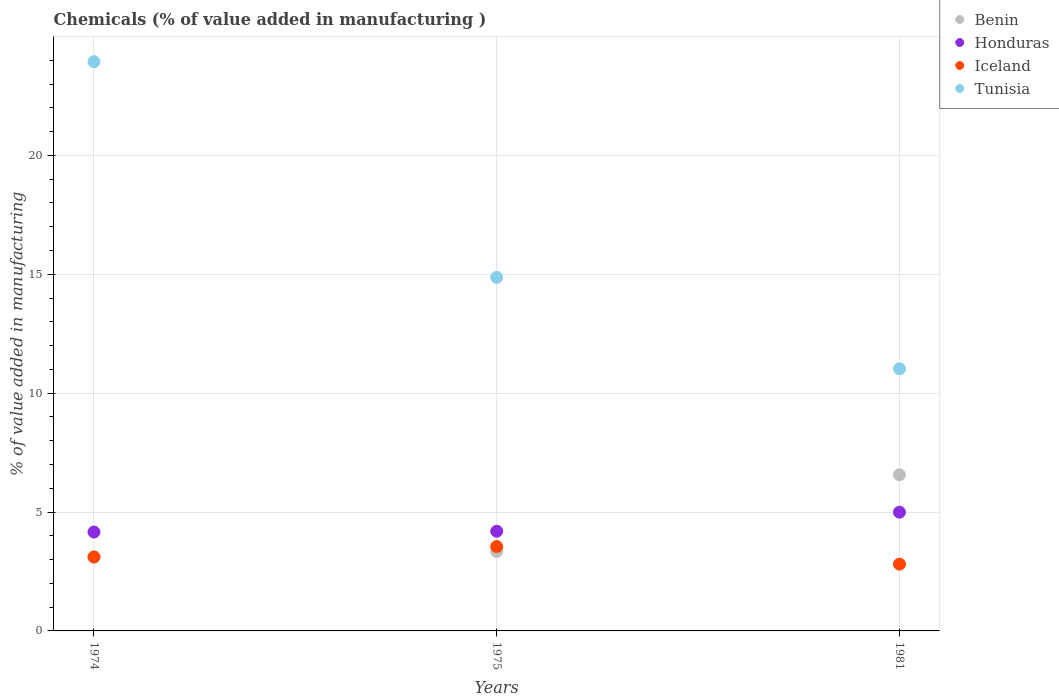Is the number of dotlines equal to the number of legend labels?
Make the answer very short. Yes. What is the value added in manufacturing chemicals in Tunisia in 1974?
Offer a terse response. 23.94. Across all years, what is the maximum value added in manufacturing chemicals in Tunisia?
Offer a very short reply. 23.94. Across all years, what is the minimum value added in manufacturing chemicals in Honduras?
Give a very brief answer. 4.16. In which year was the value added in manufacturing chemicals in Benin maximum?
Provide a short and direct response. 1981. In which year was the value added in manufacturing chemicals in Benin minimum?
Your response must be concise. 1974. What is the total value added in manufacturing chemicals in Benin in the graph?
Provide a short and direct response. 13.01. What is the difference between the value added in manufacturing chemicals in Tunisia in 1974 and that in 1981?
Offer a very short reply. 12.91. What is the difference between the value added in manufacturing chemicals in Tunisia in 1975 and the value added in manufacturing chemicals in Benin in 1974?
Keep it short and to the point. 11.77. What is the average value added in manufacturing chemicals in Iceland per year?
Offer a terse response. 3.16. In the year 1975, what is the difference between the value added in manufacturing chemicals in Iceland and value added in manufacturing chemicals in Tunisia?
Make the answer very short. -11.32. What is the ratio of the value added in manufacturing chemicals in Iceland in 1974 to that in 1981?
Make the answer very short. 1.11. Is the value added in manufacturing chemicals in Tunisia in 1975 less than that in 1981?
Your response must be concise. No. What is the difference between the highest and the second highest value added in manufacturing chemicals in Tunisia?
Offer a terse response. 9.07. What is the difference between the highest and the lowest value added in manufacturing chemicals in Iceland?
Offer a terse response. 0.74. Is the sum of the value added in manufacturing chemicals in Iceland in 1974 and 1981 greater than the maximum value added in manufacturing chemicals in Tunisia across all years?
Your answer should be compact. No. Is it the case that in every year, the sum of the value added in manufacturing chemicals in Honduras and value added in manufacturing chemicals in Tunisia  is greater than the value added in manufacturing chemicals in Iceland?
Your answer should be very brief. Yes. Does the value added in manufacturing chemicals in Honduras monotonically increase over the years?
Ensure brevity in your answer.  Yes. Are the values on the major ticks of Y-axis written in scientific E-notation?
Your answer should be compact. No. How many legend labels are there?
Your answer should be very brief. 4. How are the legend labels stacked?
Keep it short and to the point. Vertical. What is the title of the graph?
Make the answer very short. Chemicals (% of value added in manufacturing ). Does "Brunei Darussalam" appear as one of the legend labels in the graph?
Provide a short and direct response. No. What is the label or title of the X-axis?
Your answer should be very brief. Years. What is the label or title of the Y-axis?
Offer a terse response. % of value added in manufacturing. What is the % of value added in manufacturing of Benin in 1974?
Give a very brief answer. 3.1. What is the % of value added in manufacturing in Honduras in 1974?
Provide a succinct answer. 4.16. What is the % of value added in manufacturing in Iceland in 1974?
Your answer should be very brief. 3.11. What is the % of value added in manufacturing of Tunisia in 1974?
Make the answer very short. 23.94. What is the % of value added in manufacturing of Benin in 1975?
Ensure brevity in your answer.  3.34. What is the % of value added in manufacturing of Honduras in 1975?
Offer a very short reply. 4.19. What is the % of value added in manufacturing of Iceland in 1975?
Ensure brevity in your answer.  3.55. What is the % of value added in manufacturing of Tunisia in 1975?
Your response must be concise. 14.87. What is the % of value added in manufacturing in Benin in 1981?
Ensure brevity in your answer.  6.57. What is the % of value added in manufacturing of Honduras in 1981?
Provide a succinct answer. 4.99. What is the % of value added in manufacturing in Iceland in 1981?
Keep it short and to the point. 2.81. What is the % of value added in manufacturing of Tunisia in 1981?
Keep it short and to the point. 11.02. Across all years, what is the maximum % of value added in manufacturing of Benin?
Make the answer very short. 6.57. Across all years, what is the maximum % of value added in manufacturing in Honduras?
Your answer should be very brief. 4.99. Across all years, what is the maximum % of value added in manufacturing of Iceland?
Make the answer very short. 3.55. Across all years, what is the maximum % of value added in manufacturing of Tunisia?
Give a very brief answer. 23.94. Across all years, what is the minimum % of value added in manufacturing of Benin?
Provide a short and direct response. 3.1. Across all years, what is the minimum % of value added in manufacturing in Honduras?
Give a very brief answer. 4.16. Across all years, what is the minimum % of value added in manufacturing in Iceland?
Your response must be concise. 2.81. Across all years, what is the minimum % of value added in manufacturing in Tunisia?
Offer a terse response. 11.02. What is the total % of value added in manufacturing in Benin in the graph?
Keep it short and to the point. 13.01. What is the total % of value added in manufacturing of Honduras in the graph?
Offer a very short reply. 13.35. What is the total % of value added in manufacturing of Iceland in the graph?
Make the answer very short. 9.47. What is the total % of value added in manufacturing in Tunisia in the graph?
Offer a very short reply. 49.83. What is the difference between the % of value added in manufacturing in Benin in 1974 and that in 1975?
Your answer should be very brief. -0.24. What is the difference between the % of value added in manufacturing of Honduras in 1974 and that in 1975?
Your answer should be compact. -0.03. What is the difference between the % of value added in manufacturing in Iceland in 1974 and that in 1975?
Offer a terse response. -0.44. What is the difference between the % of value added in manufacturing of Tunisia in 1974 and that in 1975?
Make the answer very short. 9.07. What is the difference between the % of value added in manufacturing of Benin in 1974 and that in 1981?
Offer a very short reply. -3.47. What is the difference between the % of value added in manufacturing of Honduras in 1974 and that in 1981?
Your answer should be very brief. -0.83. What is the difference between the % of value added in manufacturing in Iceland in 1974 and that in 1981?
Your answer should be very brief. 0.3. What is the difference between the % of value added in manufacturing in Tunisia in 1974 and that in 1981?
Offer a very short reply. 12.91. What is the difference between the % of value added in manufacturing of Benin in 1975 and that in 1981?
Offer a very short reply. -3.23. What is the difference between the % of value added in manufacturing of Honduras in 1975 and that in 1981?
Your response must be concise. -0.8. What is the difference between the % of value added in manufacturing in Iceland in 1975 and that in 1981?
Offer a terse response. 0.74. What is the difference between the % of value added in manufacturing of Tunisia in 1975 and that in 1981?
Provide a short and direct response. 3.84. What is the difference between the % of value added in manufacturing in Benin in 1974 and the % of value added in manufacturing in Honduras in 1975?
Provide a short and direct response. -1.09. What is the difference between the % of value added in manufacturing in Benin in 1974 and the % of value added in manufacturing in Iceland in 1975?
Your answer should be very brief. -0.45. What is the difference between the % of value added in manufacturing of Benin in 1974 and the % of value added in manufacturing of Tunisia in 1975?
Keep it short and to the point. -11.77. What is the difference between the % of value added in manufacturing of Honduras in 1974 and the % of value added in manufacturing of Iceland in 1975?
Offer a terse response. 0.61. What is the difference between the % of value added in manufacturing in Honduras in 1974 and the % of value added in manufacturing in Tunisia in 1975?
Provide a short and direct response. -10.71. What is the difference between the % of value added in manufacturing of Iceland in 1974 and the % of value added in manufacturing of Tunisia in 1975?
Give a very brief answer. -11.75. What is the difference between the % of value added in manufacturing in Benin in 1974 and the % of value added in manufacturing in Honduras in 1981?
Your response must be concise. -1.9. What is the difference between the % of value added in manufacturing in Benin in 1974 and the % of value added in manufacturing in Iceland in 1981?
Provide a succinct answer. 0.29. What is the difference between the % of value added in manufacturing of Benin in 1974 and the % of value added in manufacturing of Tunisia in 1981?
Provide a short and direct response. -7.93. What is the difference between the % of value added in manufacturing of Honduras in 1974 and the % of value added in manufacturing of Iceland in 1981?
Your answer should be compact. 1.35. What is the difference between the % of value added in manufacturing in Honduras in 1974 and the % of value added in manufacturing in Tunisia in 1981?
Provide a succinct answer. -6.87. What is the difference between the % of value added in manufacturing in Iceland in 1974 and the % of value added in manufacturing in Tunisia in 1981?
Keep it short and to the point. -7.91. What is the difference between the % of value added in manufacturing of Benin in 1975 and the % of value added in manufacturing of Honduras in 1981?
Offer a very short reply. -1.65. What is the difference between the % of value added in manufacturing in Benin in 1975 and the % of value added in manufacturing in Iceland in 1981?
Provide a succinct answer. 0.53. What is the difference between the % of value added in manufacturing in Benin in 1975 and the % of value added in manufacturing in Tunisia in 1981?
Your response must be concise. -7.68. What is the difference between the % of value added in manufacturing in Honduras in 1975 and the % of value added in manufacturing in Iceland in 1981?
Your answer should be very brief. 1.38. What is the difference between the % of value added in manufacturing of Honduras in 1975 and the % of value added in manufacturing of Tunisia in 1981?
Offer a terse response. -6.83. What is the difference between the % of value added in manufacturing of Iceland in 1975 and the % of value added in manufacturing of Tunisia in 1981?
Make the answer very short. -7.48. What is the average % of value added in manufacturing in Benin per year?
Your response must be concise. 4.34. What is the average % of value added in manufacturing of Honduras per year?
Provide a short and direct response. 4.45. What is the average % of value added in manufacturing in Iceland per year?
Provide a succinct answer. 3.16. What is the average % of value added in manufacturing in Tunisia per year?
Your answer should be very brief. 16.61. In the year 1974, what is the difference between the % of value added in manufacturing of Benin and % of value added in manufacturing of Honduras?
Your answer should be very brief. -1.06. In the year 1974, what is the difference between the % of value added in manufacturing in Benin and % of value added in manufacturing in Iceland?
Keep it short and to the point. -0.01. In the year 1974, what is the difference between the % of value added in manufacturing of Benin and % of value added in manufacturing of Tunisia?
Ensure brevity in your answer.  -20.84. In the year 1974, what is the difference between the % of value added in manufacturing in Honduras and % of value added in manufacturing in Iceland?
Your response must be concise. 1.05. In the year 1974, what is the difference between the % of value added in manufacturing of Honduras and % of value added in manufacturing of Tunisia?
Give a very brief answer. -19.78. In the year 1974, what is the difference between the % of value added in manufacturing of Iceland and % of value added in manufacturing of Tunisia?
Offer a very short reply. -20.83. In the year 1975, what is the difference between the % of value added in manufacturing in Benin and % of value added in manufacturing in Honduras?
Make the answer very short. -0.85. In the year 1975, what is the difference between the % of value added in manufacturing in Benin and % of value added in manufacturing in Iceland?
Make the answer very short. -0.21. In the year 1975, what is the difference between the % of value added in manufacturing in Benin and % of value added in manufacturing in Tunisia?
Make the answer very short. -11.53. In the year 1975, what is the difference between the % of value added in manufacturing in Honduras and % of value added in manufacturing in Iceland?
Provide a short and direct response. 0.65. In the year 1975, what is the difference between the % of value added in manufacturing in Honduras and % of value added in manufacturing in Tunisia?
Keep it short and to the point. -10.67. In the year 1975, what is the difference between the % of value added in manufacturing in Iceland and % of value added in manufacturing in Tunisia?
Your answer should be compact. -11.32. In the year 1981, what is the difference between the % of value added in manufacturing in Benin and % of value added in manufacturing in Honduras?
Offer a very short reply. 1.57. In the year 1981, what is the difference between the % of value added in manufacturing in Benin and % of value added in manufacturing in Iceland?
Make the answer very short. 3.76. In the year 1981, what is the difference between the % of value added in manufacturing of Benin and % of value added in manufacturing of Tunisia?
Offer a very short reply. -4.46. In the year 1981, what is the difference between the % of value added in manufacturing of Honduras and % of value added in manufacturing of Iceland?
Provide a short and direct response. 2.18. In the year 1981, what is the difference between the % of value added in manufacturing in Honduras and % of value added in manufacturing in Tunisia?
Provide a succinct answer. -6.03. In the year 1981, what is the difference between the % of value added in manufacturing in Iceland and % of value added in manufacturing in Tunisia?
Make the answer very short. -8.22. What is the ratio of the % of value added in manufacturing in Benin in 1974 to that in 1975?
Your answer should be very brief. 0.93. What is the ratio of the % of value added in manufacturing in Honduras in 1974 to that in 1975?
Keep it short and to the point. 0.99. What is the ratio of the % of value added in manufacturing of Iceland in 1974 to that in 1975?
Your answer should be very brief. 0.88. What is the ratio of the % of value added in manufacturing of Tunisia in 1974 to that in 1975?
Offer a terse response. 1.61. What is the ratio of the % of value added in manufacturing in Benin in 1974 to that in 1981?
Offer a terse response. 0.47. What is the ratio of the % of value added in manufacturing in Honduras in 1974 to that in 1981?
Offer a terse response. 0.83. What is the ratio of the % of value added in manufacturing in Iceland in 1974 to that in 1981?
Offer a terse response. 1.11. What is the ratio of the % of value added in manufacturing in Tunisia in 1974 to that in 1981?
Make the answer very short. 2.17. What is the ratio of the % of value added in manufacturing in Benin in 1975 to that in 1981?
Give a very brief answer. 0.51. What is the ratio of the % of value added in manufacturing in Honduras in 1975 to that in 1981?
Make the answer very short. 0.84. What is the ratio of the % of value added in manufacturing in Iceland in 1975 to that in 1981?
Your answer should be very brief. 1.26. What is the ratio of the % of value added in manufacturing of Tunisia in 1975 to that in 1981?
Your response must be concise. 1.35. What is the difference between the highest and the second highest % of value added in manufacturing of Benin?
Keep it short and to the point. 3.23. What is the difference between the highest and the second highest % of value added in manufacturing of Honduras?
Offer a very short reply. 0.8. What is the difference between the highest and the second highest % of value added in manufacturing in Iceland?
Provide a short and direct response. 0.44. What is the difference between the highest and the second highest % of value added in manufacturing in Tunisia?
Your response must be concise. 9.07. What is the difference between the highest and the lowest % of value added in manufacturing of Benin?
Offer a very short reply. 3.47. What is the difference between the highest and the lowest % of value added in manufacturing of Honduras?
Provide a succinct answer. 0.83. What is the difference between the highest and the lowest % of value added in manufacturing of Iceland?
Ensure brevity in your answer.  0.74. What is the difference between the highest and the lowest % of value added in manufacturing in Tunisia?
Provide a short and direct response. 12.91. 